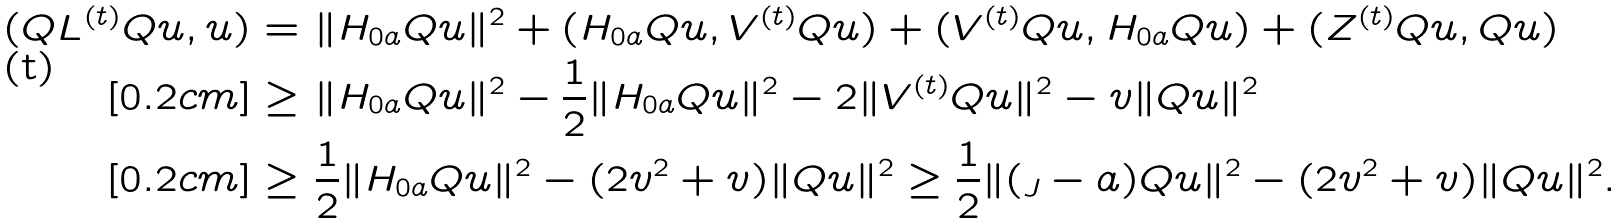<formula> <loc_0><loc_0><loc_500><loc_500>( Q L ^ { ( t ) } Q u , u ) = & \ \| H _ { 0 a } Q u \| ^ { 2 } + ( H _ { 0 a } Q u , V ^ { ( t ) } Q u ) + ( V ^ { ( t ) } Q u , H _ { 0 a } Q u ) + ( Z ^ { ( t ) } Q u , Q u ) \\ [ 0 . 2 c m ] \geq & \ \| H _ { 0 a } Q u \| ^ { 2 } - \frac { 1 } { 2 } \| H _ { 0 a } Q u \| ^ { 2 } - 2 \| V ^ { ( t ) } Q u \| ^ { 2 } - v \| Q u \| ^ { 2 } \\ [ 0 . 2 c m ] \geq & \ \frac { 1 } { 2 } \| H _ { 0 a } Q u \| ^ { 2 } - ( 2 v ^ { 2 } + v ) \| Q u \| ^ { 2 } \geq \frac { 1 } { 2 } \| ( \L _ { J } - a ) Q u \| ^ { 2 } - ( 2 v ^ { 2 } + v ) \| Q u \| ^ { 2 } .</formula> 